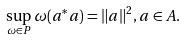<formula> <loc_0><loc_0><loc_500><loc_500>\sup _ { \omega \in P } \omega ( a ^ { * } a ) = \| a \| ^ { 2 } , a \in A .</formula> 